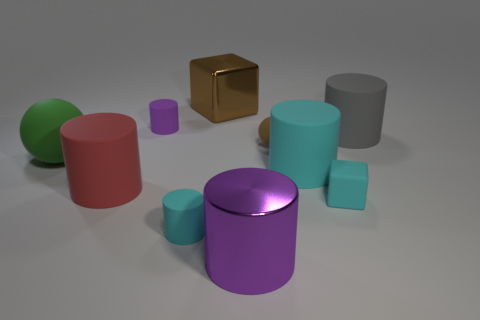Is the size of the gray thing the same as the green matte object?
Offer a terse response. Yes. There is a block that is made of the same material as the tiny cyan cylinder; what is its size?
Your answer should be compact. Small. What is the size of the cube in front of the purple cylinder that is to the left of the large metal thing that is on the right side of the large brown block?
Provide a short and direct response. Small. There is a rubber ball on the left side of the big shiny block; what is its color?
Ensure brevity in your answer.  Green. Is the number of brown blocks that are behind the small brown matte thing greater than the number of tiny yellow shiny spheres?
Your answer should be compact. Yes. There is a large metallic thing that is in front of the green rubber thing; is it the same shape as the red matte object?
Make the answer very short. Yes. How many brown things are balls or big matte objects?
Offer a very short reply. 1. Is the number of big red matte things greater than the number of cylinders?
Make the answer very short. No. What color is the shiny cube that is the same size as the red rubber object?
Your response must be concise. Brown. What number of cubes are gray objects or small cyan rubber things?
Offer a very short reply. 1. 